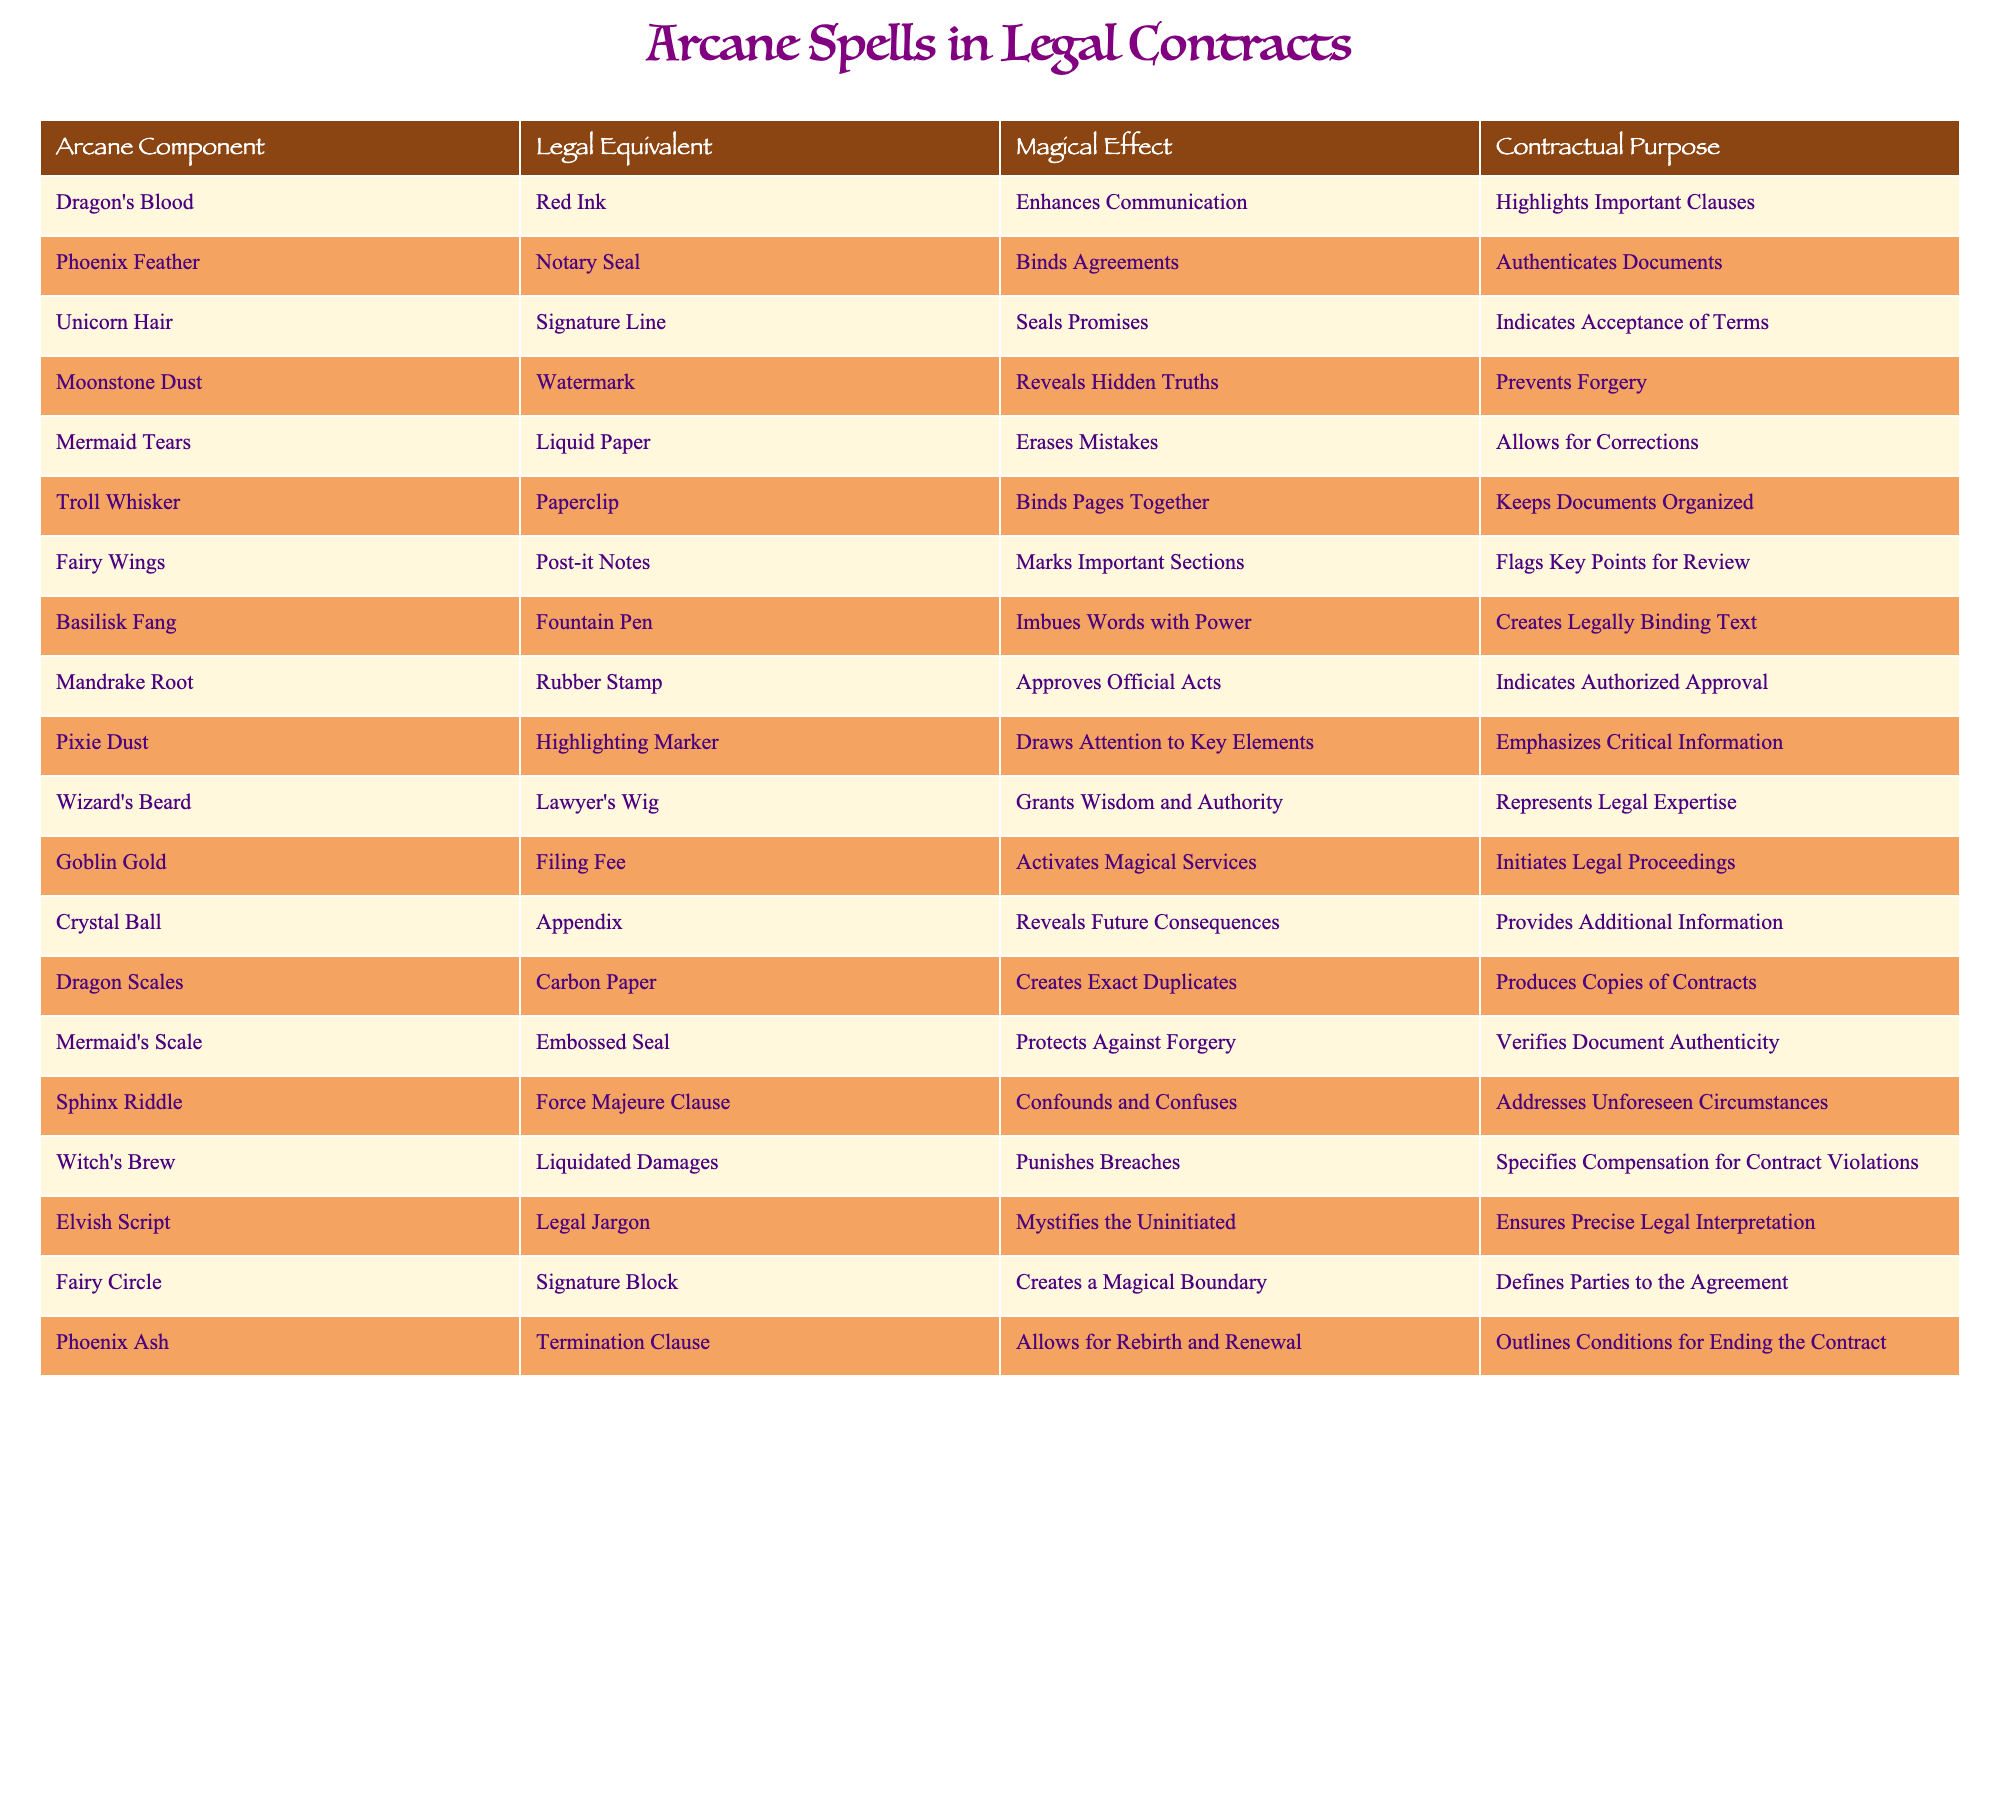What is the legal equivalent of Dragon's Blood? The table indicates that the legal equivalent of Dragon's Blood is Red Ink.
Answer: Red Ink Which magical effect is associated with Unicorn Hair? According to the table, Unicorn Hair enhances communication, which is its magical effect.
Answer: Enhances Communication What do Mermaid Tears help with in a contract context? The table states that Mermaid Tears allow for corrections, which means they help erase mistakes.
Answer: Allows for Corrections Is a Notary Seal considered a binding agreement mechanism? Yes, it is indicated in the table that a Notary Seal binds agreements.
Answer: Yes Which arcane component's legal equivalent is the Highlighting Marker? The table specifies that Pixie Dust corresponds to the Highlighting Marker in legal terms.
Answer: Pixie Dust What would be the outcome of adding Troll Whisker and Fairy Wings in a contract? Troll Whisker binds pages together, while Fairy Wings mark important sections; together, they would keep the document organized and flag key points.
Answer: Organized and flagged document How many magical effects are related to the components that ensure document authenticity? Looking at the table, both Mermaid's Scale and Phoenix Feather relate to authenticity, giving a total of two components.
Answer: 2 What is the function of a Sphinx Riddle in legal terms? The Sphinx Riddle functions as a Force Majeure Clause, addressing unforeseen circumstances.
Answer: Addresses Unforeseen Circumstances If you were to find a document that needs a correction, which arcane component would be most suitable? Mermaid Tears are indicated to help erase mistakes, making it the most suitable component for corrections.
Answer: Mermaid Tears What are the consequences if a contract includes a Termination Clause, according to the table? The Termination Clause, associated with Phoenix Ash, allows for rebirth and renewal, outlining conditions for ending the contract.
Answer: Allows for rebirth and renewal How do you ensure a contract is legally binding? You would use a combination of components like a Signature Line for acceptance and a Fountain Pen to ensure the text is imbued with power.
Answer: Signature Line and Fountain Pen 